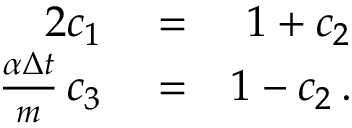Convert formula to latex. <formula><loc_0><loc_0><loc_500><loc_500>\begin{array} { r l r } { 2 c _ { 1 } } & = } & { 1 + c _ { 2 } } \\ { \frac { \alpha \Delta { t } } { m } \, c _ { 3 } } & = } & { 1 - c _ { 2 } \, . } \end{array}</formula> 